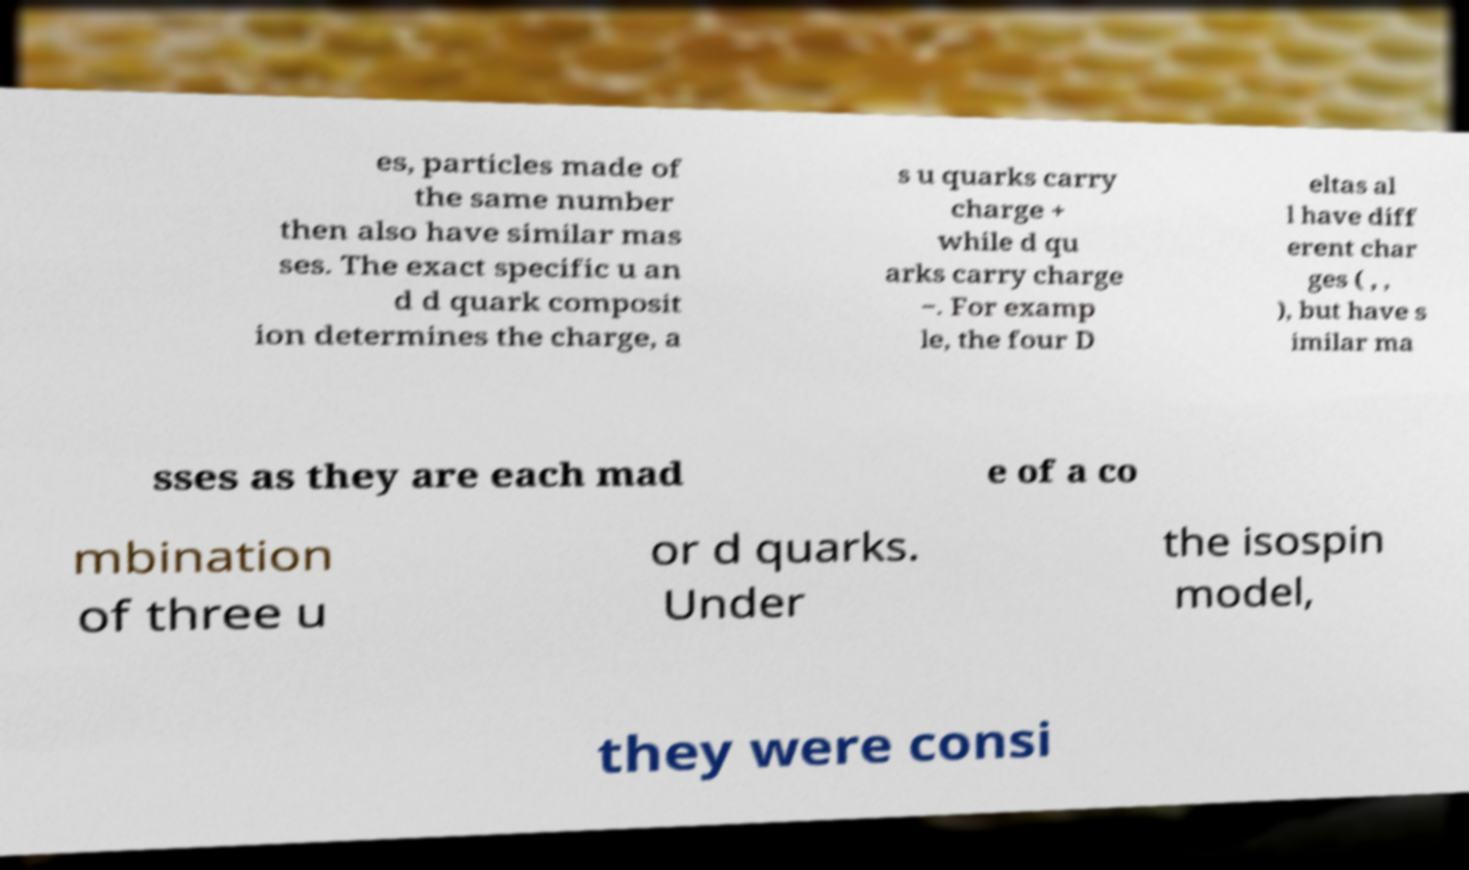I need the written content from this picture converted into text. Can you do that? es, particles made of the same number then also have similar mas ses. The exact specific u an d d quark composit ion determines the charge, a s u quarks carry charge + while d qu arks carry charge −. For examp le, the four D eltas al l have diff erent char ges ( , , ), but have s imilar ma sses as they are each mad e of a co mbination of three u or d quarks. Under the isospin model, they were consi 